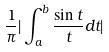<formula> <loc_0><loc_0><loc_500><loc_500>\frac { 1 } { \pi } | \int _ { a } ^ { b } \frac { \sin t } { t } d t |</formula> 